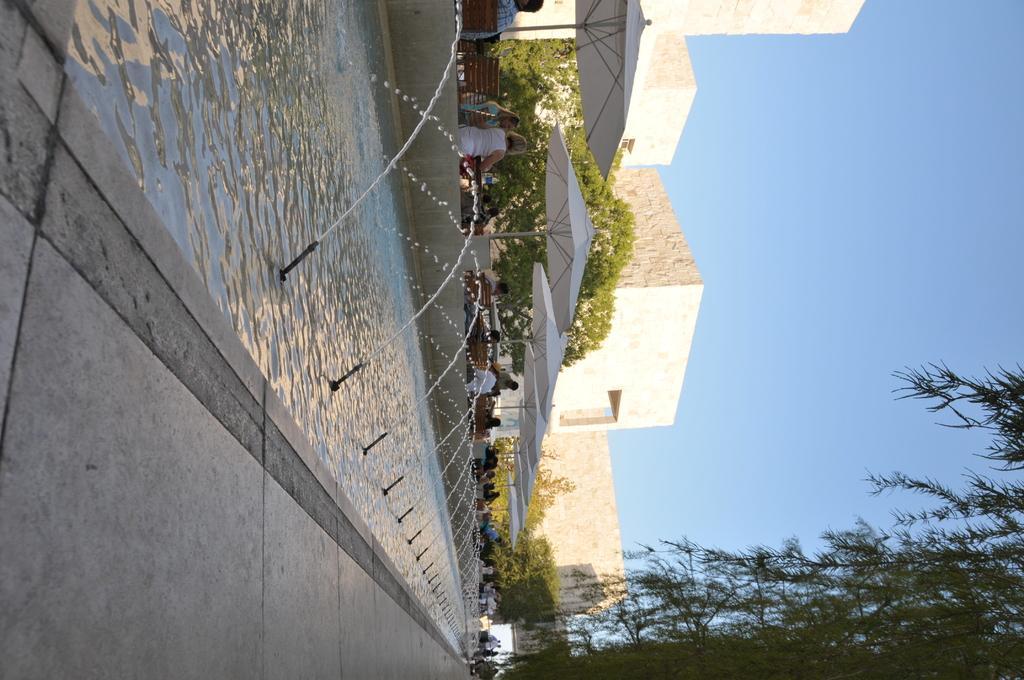In one or two sentences, can you explain what this image depicts? In the foreground of this image, there is a path and tree on the bottom. In the middle, there is water and few sprinklers in it. In the background, there are trees, umbrellas, chairs, person sitting under umbrellas, few buildings and the sky. 